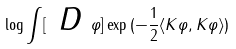<formula> <loc_0><loc_0><loc_500><loc_500>\log \int [ \emph { D } \varphi ] \exp { ( - \frac { 1 } { 2 } \langle K \varphi , K \varphi \rangle } )</formula> 